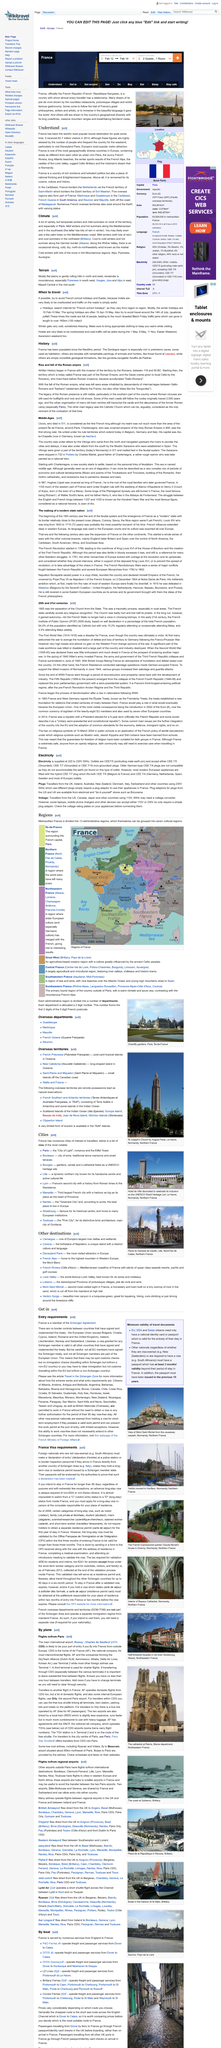Identify some key points in this picture. Do you comprehend that Europe's most frequented tourist attraction is Disneyland Paris? In 2014, 83.7 million people visited France. The French Alps are renowned for their world-class winter sports resorts, attracting throngs of adventure-seekers each year. These snow-capped peaks offer an unparalleled playground for skiers and snowboarders of all abilities, as well as a wealth of other winter activities. 